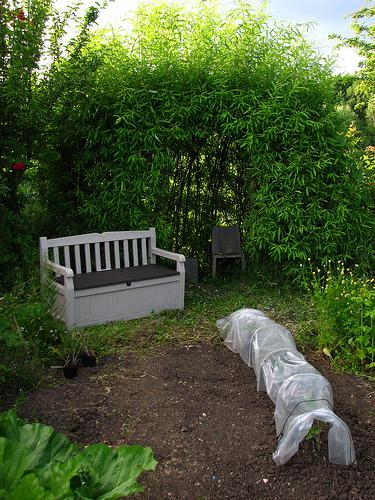Question: how many benches are there?
Choices:
A. One.
B. Two.
C. Three.
D. Four.
Answer with the letter. Answer: A Question: what color is the bench seat?
Choices:
A. Black.
B. White.
C. Brown.
D. Orange.
Answer with the letter. Answer: C Question: what color is the grass?
Choices:
A. Brown.
B. Beige.
C. Green.
D. Yellow.
Answer with the letter. Answer: C Question: what is the plastic covering?
Choices:
A. The produce.
B. The leftovers.
C. Plants.
D. The car.
Answer with the letter. Answer: C Question: what color is the plastic?
Choices:
A. White.
B. Blue.
C. Yellow.
D. Transparent.
Answer with the letter. Answer: D Question: why are the plants covered up?
Choices:
A. Protect them.
B. To trap the heat when it is cold.
C. To keep frost off of them.
D. To keep them warm.
Answer with the letter. Answer: A 